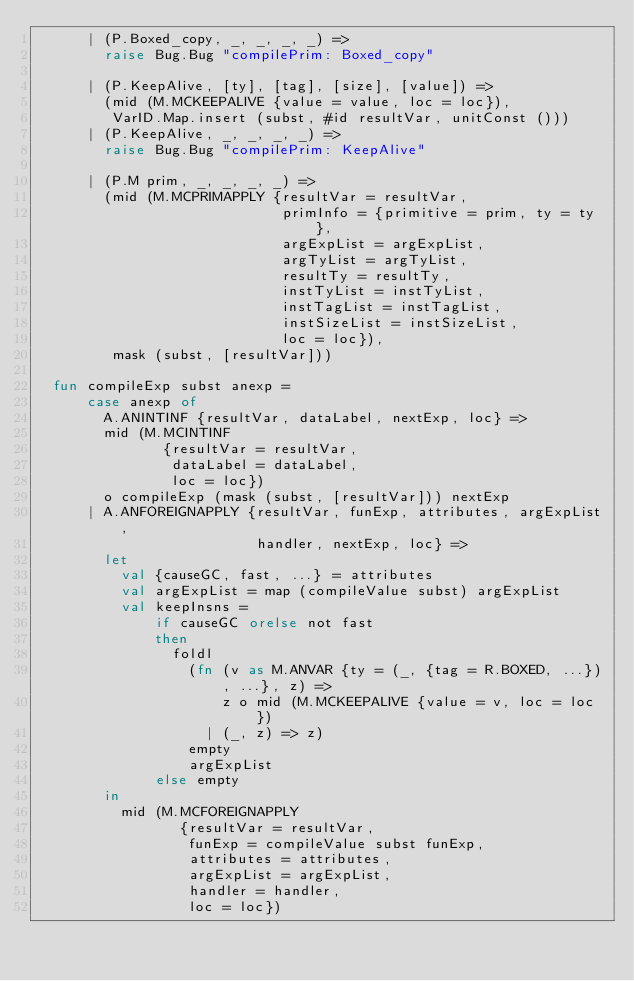Convert code to text. <code><loc_0><loc_0><loc_500><loc_500><_SML_>      | (P.Boxed_copy, _, _, _, _) =>
        raise Bug.Bug "compilePrim: Boxed_copy"

      | (P.KeepAlive, [ty], [tag], [size], [value]) =>
        (mid (M.MCKEEPALIVE {value = value, loc = loc}),
         VarID.Map.insert (subst, #id resultVar, unitConst ()))
      | (P.KeepAlive, _, _, _, _) =>
        raise Bug.Bug "compilePrim: KeepAlive"

      | (P.M prim, _, _, _, _) =>
        (mid (M.MCPRIMAPPLY {resultVar = resultVar,
                             primInfo = {primitive = prim, ty = ty},
                             argExpList = argExpList,
                             argTyList = argTyList,
                             resultTy = resultTy,
                             instTyList = instTyList,
                             instTagList = instTagList,
                             instSizeList = instSizeList,
                             loc = loc}),
         mask (subst, [resultVar]))

  fun compileExp subst anexp =
      case anexp of
        A.ANINTINF {resultVar, dataLabel, nextExp, loc} =>
        mid (M.MCINTINF
               {resultVar = resultVar,
                dataLabel = dataLabel,
                loc = loc})
        o compileExp (mask (subst, [resultVar])) nextExp
      | A.ANFOREIGNAPPLY {resultVar, funExp, attributes, argExpList,
                          handler, nextExp, loc} =>
        let
          val {causeGC, fast, ...} = attributes
          val argExpList = map (compileValue subst) argExpList
          val keepInsns =
              if causeGC orelse not fast
              then
                foldl
                  (fn (v as M.ANVAR {ty = (_, {tag = R.BOXED, ...}), ...}, z) =>
                      z o mid (M.MCKEEPALIVE {value = v, loc = loc})
                    | (_, z) => z)
                  empty
                  argExpList
              else empty
        in
          mid (M.MCFOREIGNAPPLY
                 {resultVar = resultVar,
                  funExp = compileValue subst funExp,
                  attributes = attributes,
                  argExpList = argExpList,
                  handler = handler,
                  loc = loc})</code> 